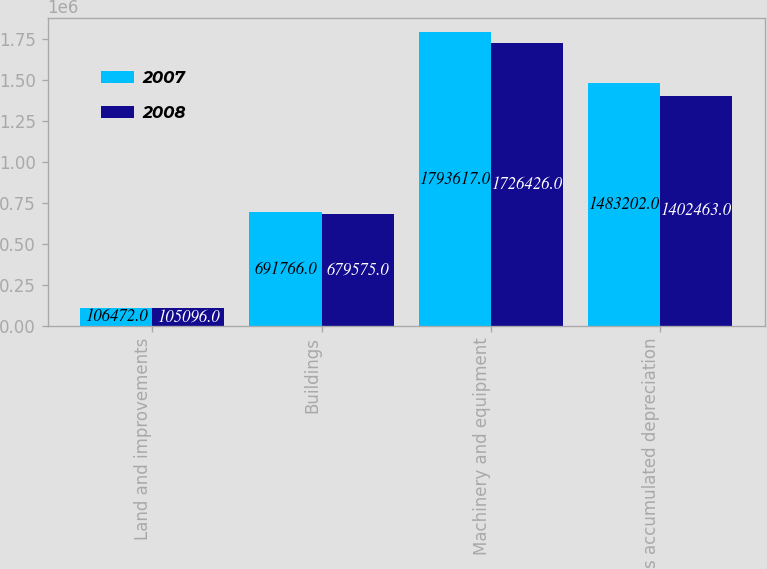Convert chart to OTSL. <chart><loc_0><loc_0><loc_500><loc_500><stacked_bar_chart><ecel><fcel>Land and improvements<fcel>Buildings<fcel>Machinery and equipment<fcel>Less accumulated depreciation<nl><fcel>2007<fcel>106472<fcel>691766<fcel>1.79362e+06<fcel>1.4832e+06<nl><fcel>2008<fcel>105096<fcel>679575<fcel>1.72643e+06<fcel>1.40246e+06<nl></chart> 